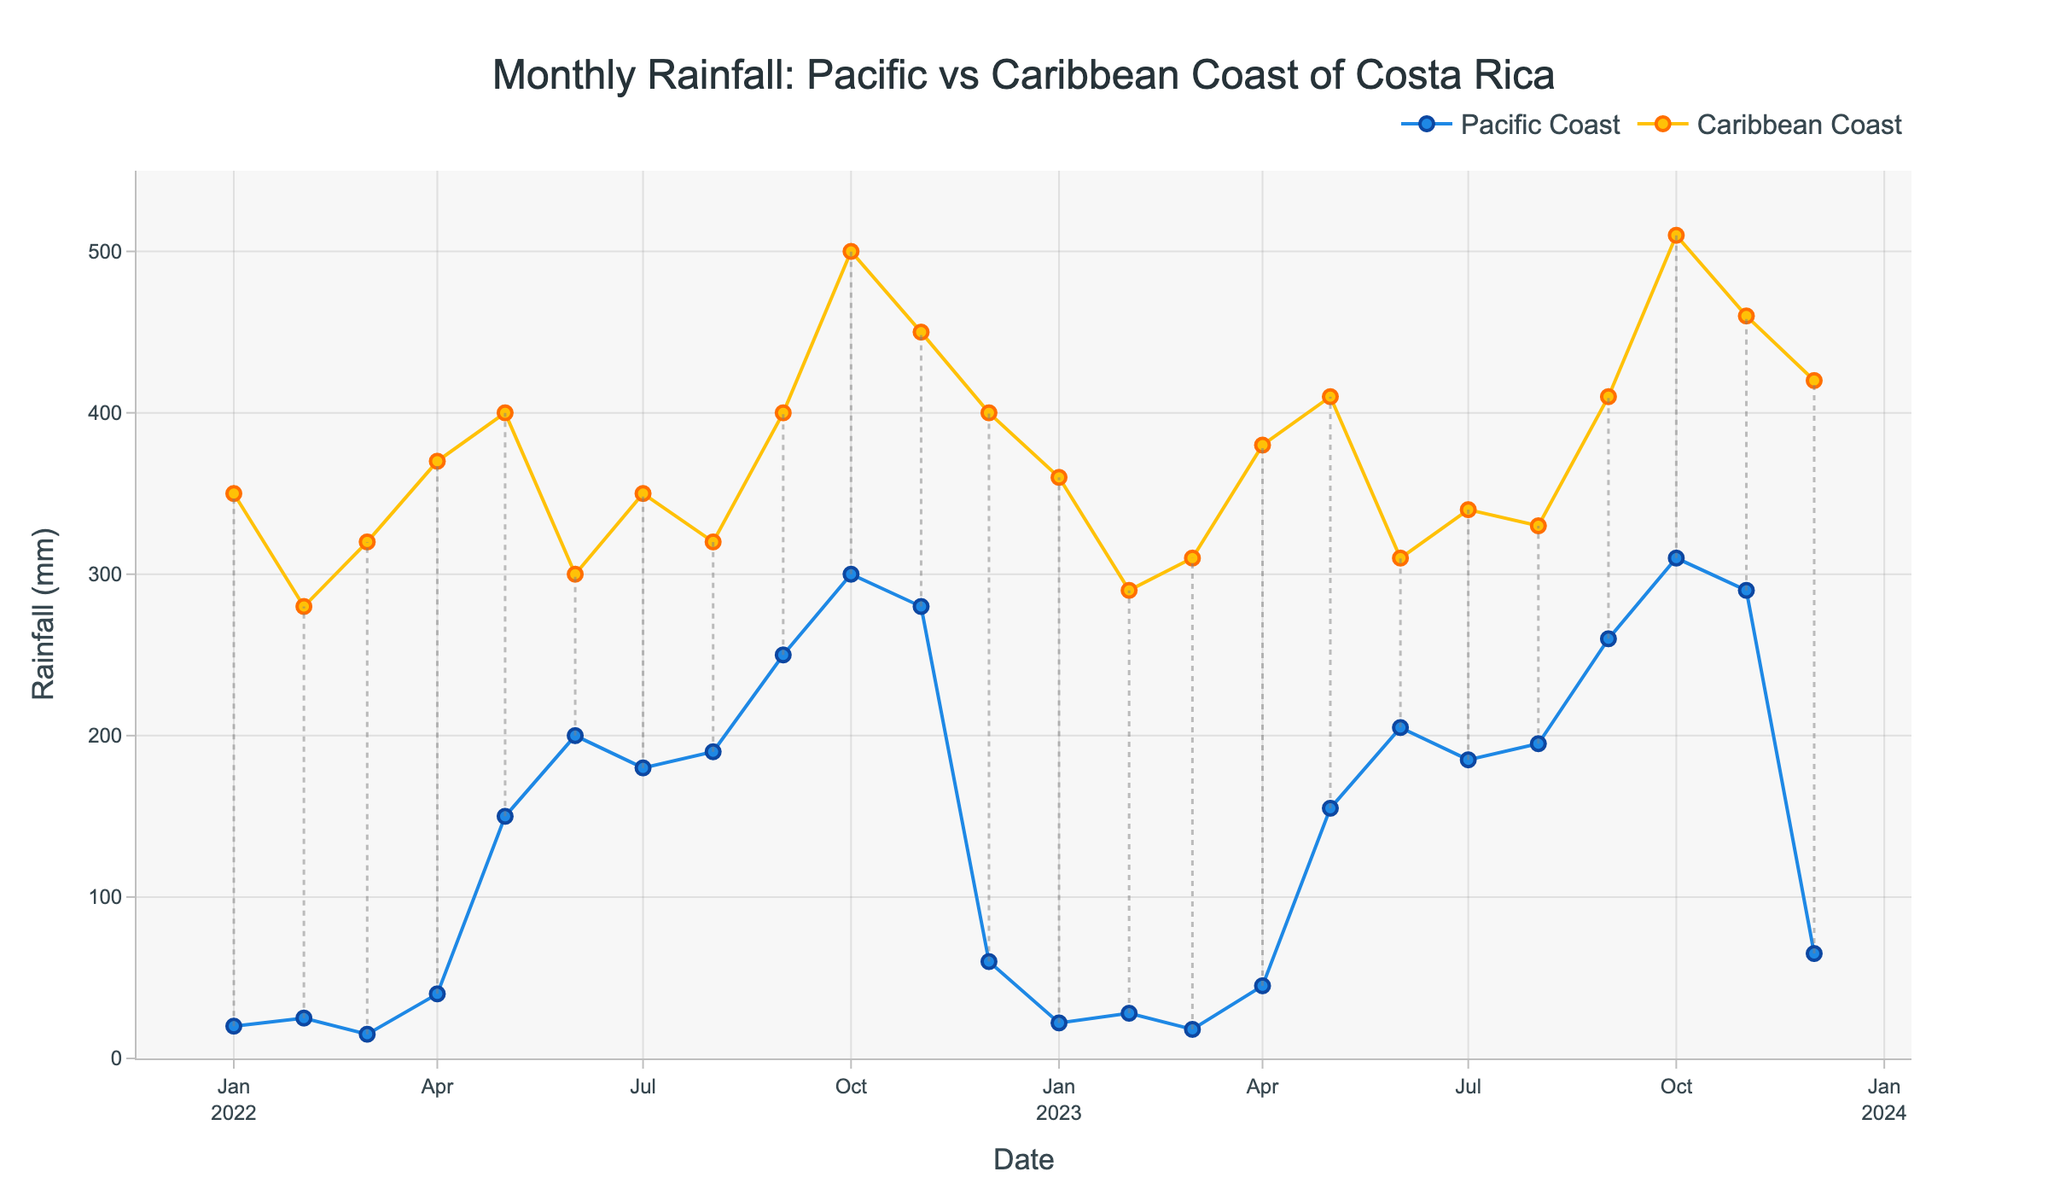What's the title of the plot? The title is shown at the top of the figure.
Answer: Monthly Rainfall: Pacific vs Caribbean Coast of Costa Rica What are the months with the highest rainfall on the Caribbean Coast? Look at the peaks of the lines for the Caribbean Coast (usually yellow markers).
Answer: October 2022 and October 2023 Which year had more rainfall in December on the Caribbean Coast? Compare the yellow line points for December in 2022 and 2023.
Answer: 2023 What's the average rainfall for the Pacific Coast in the months of January for 2022 and 2023? Add the rainfall values for January in both years for the Pacific Coast and divide by 2. (20 + 22)/2 = 21
Answer: 21 mm In which month and year was the difference between the Pacific and Caribbean coast rainfall the greatest? The largest vertical distance between blue and yellow markers indicates the greatest difference.
Answer: October 2023 Did Caribbean Coast always receive more rainfall than the Pacific Coast? Check all months' markers to see if the yellow line is always above the blue line.
Answer: Yes How does the rainfall trend on the Pacific Coast compare between January 2022 to December 2023? Observe the blue line trend from the beginning to the end of the plot.
Answer: Increasing trend During which months do the Pacific and Caribbean coasts have the most similar rainfall amounts in any year? Look for the months where the vertical distance between the blue and yellow markers is the smallest.
Answer: June 2022, June 2023 What is the approximate average annual rainfall on the Caribbean Coast for 2022? Sum up the monthly rainfall values for 2022 on the Caribbean Coast and divide by 12. (350 + 280 + 320 + 370 + 400 + 300 + 350 + 320 + 400 + 500 + 450 + 400)/12 ≈ 378.33
Answer: 378 mm 